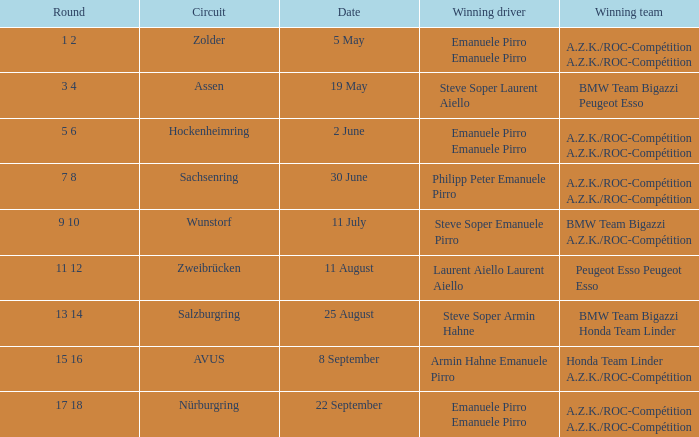Who is the winning driver of the race on 2 June with a.z.k./roc-compétition a.z.k./roc-compétition as the winning team? Emanuele Pirro Emanuele Pirro. 